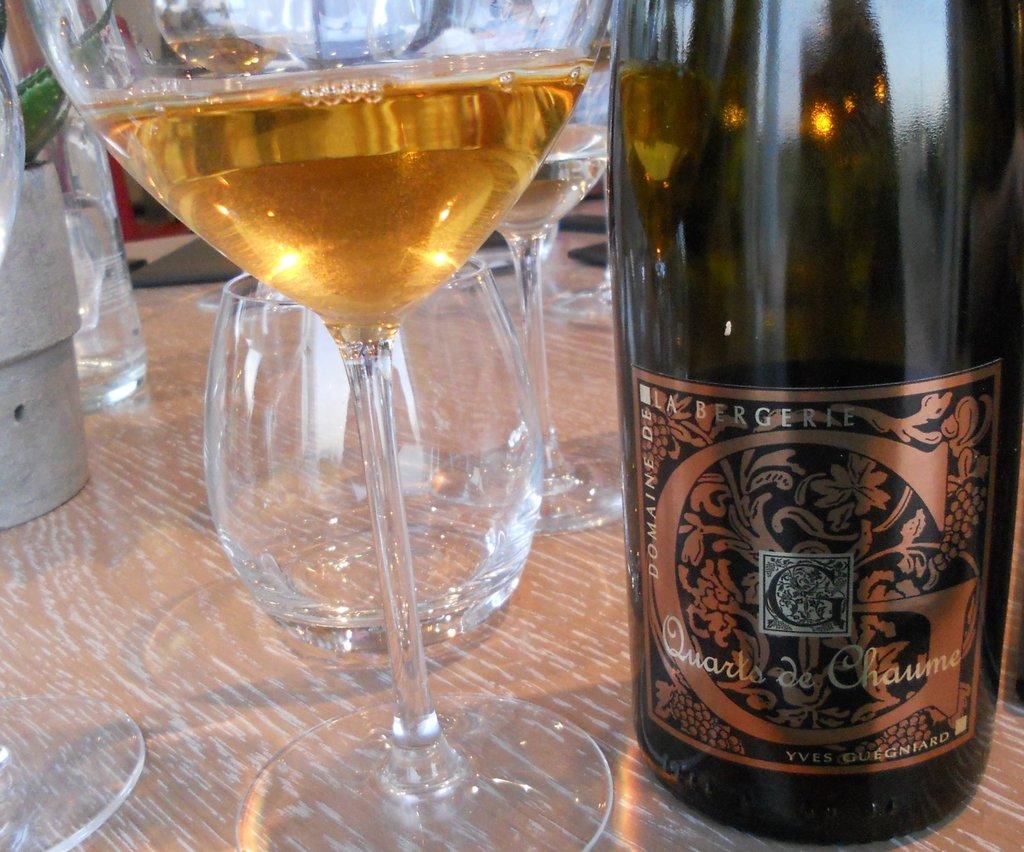What type of wine is this?
Offer a terse response. Quarts de chaume. What letter is elaborately decorated at the center of this wine label?
Keep it short and to the point. G. 